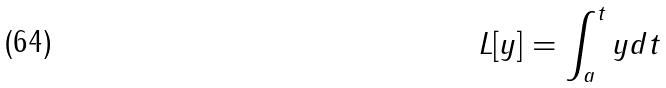<formula> <loc_0><loc_0><loc_500><loc_500>L [ y ] = \int _ { a } ^ { t } y d t</formula> 